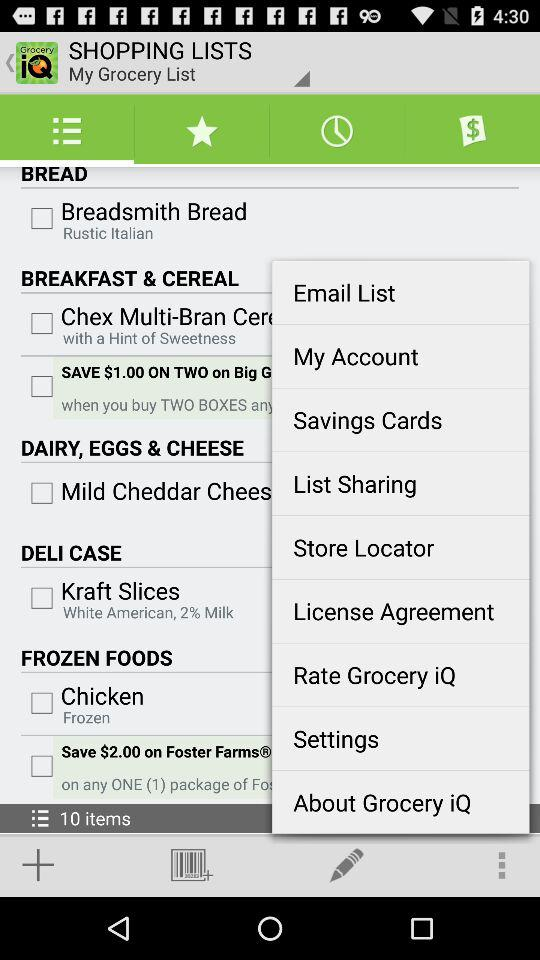What is the total number of items? The total number of items is 10. 